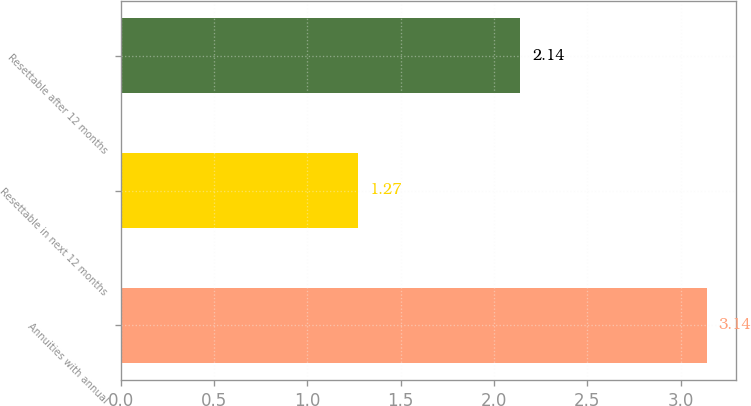Convert chart to OTSL. <chart><loc_0><loc_0><loc_500><loc_500><bar_chart><fcel>Annuities with annual<fcel>Resettable in next 12 months<fcel>Resettable after 12 months<nl><fcel>3.14<fcel>1.27<fcel>2.14<nl></chart> 